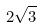<formula> <loc_0><loc_0><loc_500><loc_500>2 \sqrt { 3 }</formula> 